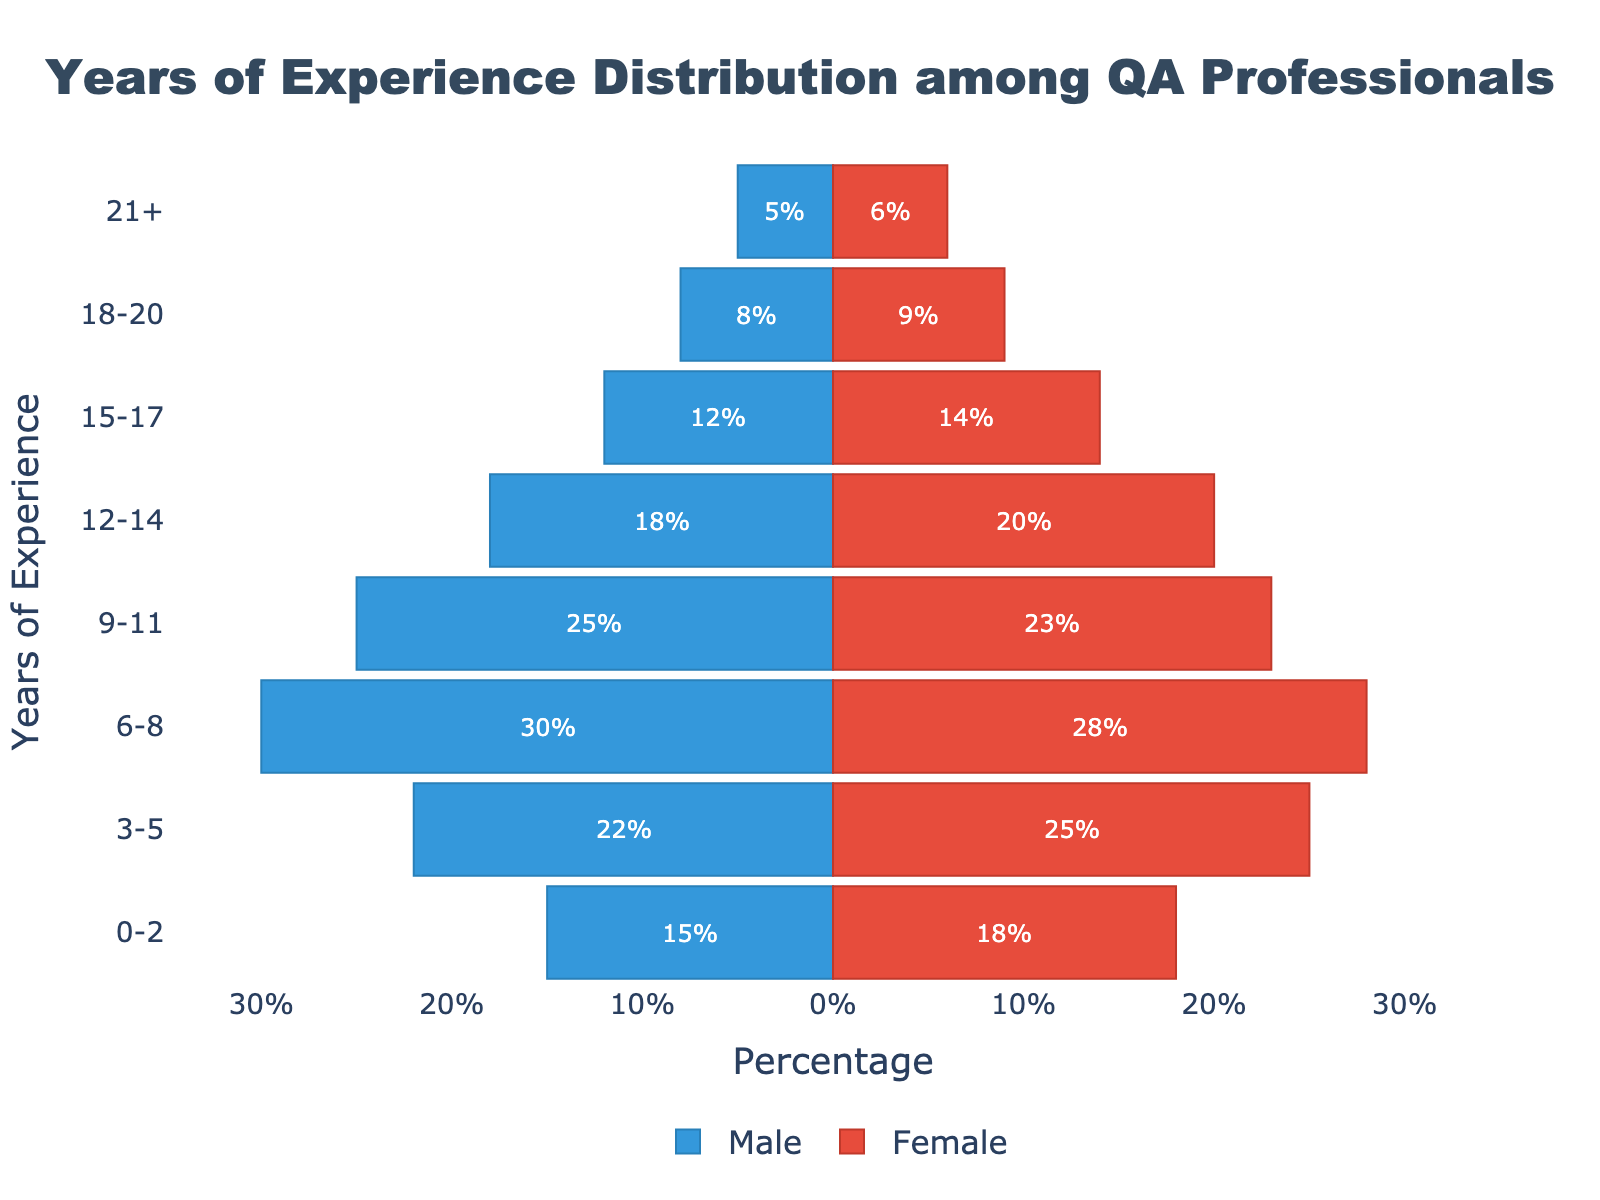What's the title of the figure? The title is usually displayed at the top of the figure. In this case, it reads "Years of Experience Distribution among QA Professionals".
Answer: Years of Experience Distribution among QA Professionals What is the age range with the highest number of female QA professionals? Look at the bars representing females and identify the longest bar. For females, the 6-8 years range has the longest bar.
Answer: 6-8 years Which gender has the highest number of QA professionals with 0-2 years of experience? Compare the lengths of the bars for both genders within the 0-2 years range. The female bar is slightly longer than the male bar.
Answer: Female What's the total number of QA professionals with 3-5 years of experience? Add the number of male professionals (-22) and female professionals (25) and take the absolute values: 22 + 25 = 47.
Answer: 47 What is the total number of male QA professionals across all experience levels? Sum the absolute values of the male professionals in all categories: 15 + 22 + 30 + 25 + 18 + 12 + 8 + 5 = 135.
Answer: 135 Which years of experience category has more males than females? Compare the lengths of the bars for each category. The 6-8 years, 9-11 years, and 18-20 years categories have more males than females.
Answer: 6-8 years, 9-11 years, 18-20 years What's the number of female QA professionals with more than 21 years of experience? Check the bar representing females with 21+ years of experience; it has a value of 6.
Answer: 6 How many years of experience categories are represented in the figure? Count the number of different years of experience ranges listed on the vertical axis. There are 8 categories.
Answer: 8 